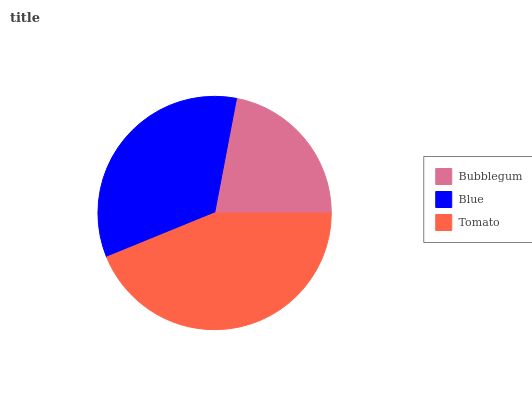Is Bubblegum the minimum?
Answer yes or no. Yes. Is Tomato the maximum?
Answer yes or no. Yes. Is Blue the minimum?
Answer yes or no. No. Is Blue the maximum?
Answer yes or no. No. Is Blue greater than Bubblegum?
Answer yes or no. Yes. Is Bubblegum less than Blue?
Answer yes or no. Yes. Is Bubblegum greater than Blue?
Answer yes or no. No. Is Blue less than Bubblegum?
Answer yes or no. No. Is Blue the high median?
Answer yes or no. Yes. Is Blue the low median?
Answer yes or no. Yes. Is Bubblegum the high median?
Answer yes or no. No. Is Tomato the low median?
Answer yes or no. No. 